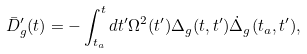<formula> <loc_0><loc_0><loc_500><loc_500>\bar { D } ^ { \prime } _ { g } ( t ) = - \int ^ { t } _ { t _ { a } } d t ^ { \prime } \Omega ^ { 2 } ( t ^ { \prime } ) \Delta _ { g } ( t , t ^ { \prime } ) \dot { \Delta } _ { g } ( t _ { a } , t ^ { \prime } ) ,</formula> 